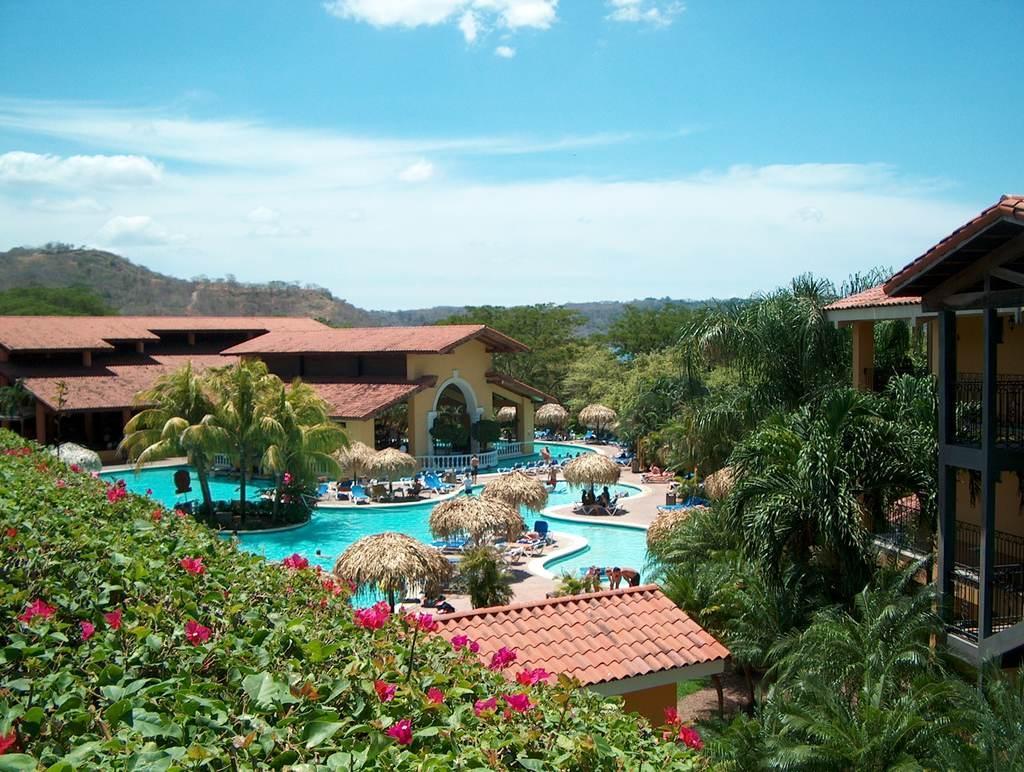Describe this image in one or two sentences. In this image we can see trees, plants, flowers, houses, swimming pool, persons, chairs, shacks, hill, sky and clouds. 